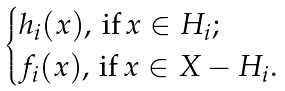Convert formula to latex. <formula><loc_0><loc_0><loc_500><loc_500>\begin{cases} h _ { i } ( x ) , \, \text {if} \, x \in H _ { i } ; \\ f _ { i } ( x ) , \, \text {if} \, x \in X - H _ { i } . \\ \end{cases}</formula> 